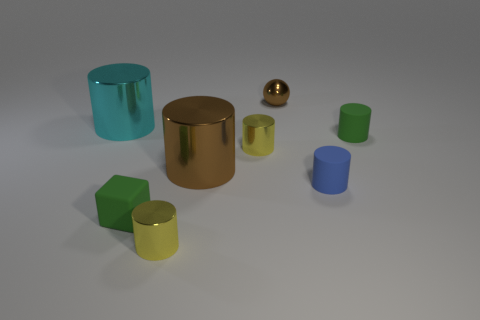How many other things are the same color as the small sphere?
Ensure brevity in your answer.  1. What number of spheres are either cyan objects or tiny brown objects?
Give a very brief answer. 1. There is a tiny rubber thing that is left of the sphere; are there any big brown metallic cylinders that are in front of it?
Ensure brevity in your answer.  No. Are there fewer brown shiny cylinders than big blue matte cylinders?
Provide a short and direct response. No. How many tiny green objects have the same shape as the big brown metal object?
Make the answer very short. 1. What number of green things are either tiny rubber cubes or small spheres?
Your response must be concise. 1. What size is the green object that is on the right side of the tiny rubber object in front of the tiny blue object?
Make the answer very short. Small. There is a brown object that is the same shape as the cyan thing; what is it made of?
Your answer should be very brief. Metal. What number of blue cylinders have the same size as the blue matte thing?
Offer a terse response. 0. Does the brown shiny ball have the same size as the brown cylinder?
Your answer should be compact. No. 